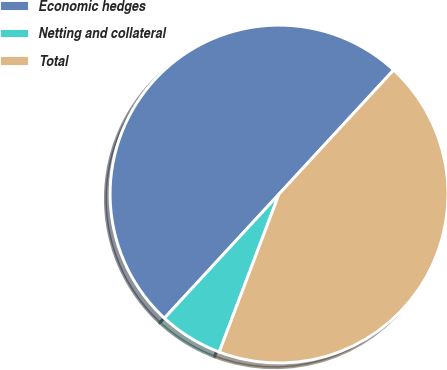Convert chart. <chart><loc_0><loc_0><loc_500><loc_500><pie_chart><fcel>Economic hedges<fcel>Netting and collateral<fcel>Total<nl><fcel>50.0%<fcel>6.11%<fcel>43.89%<nl></chart> 